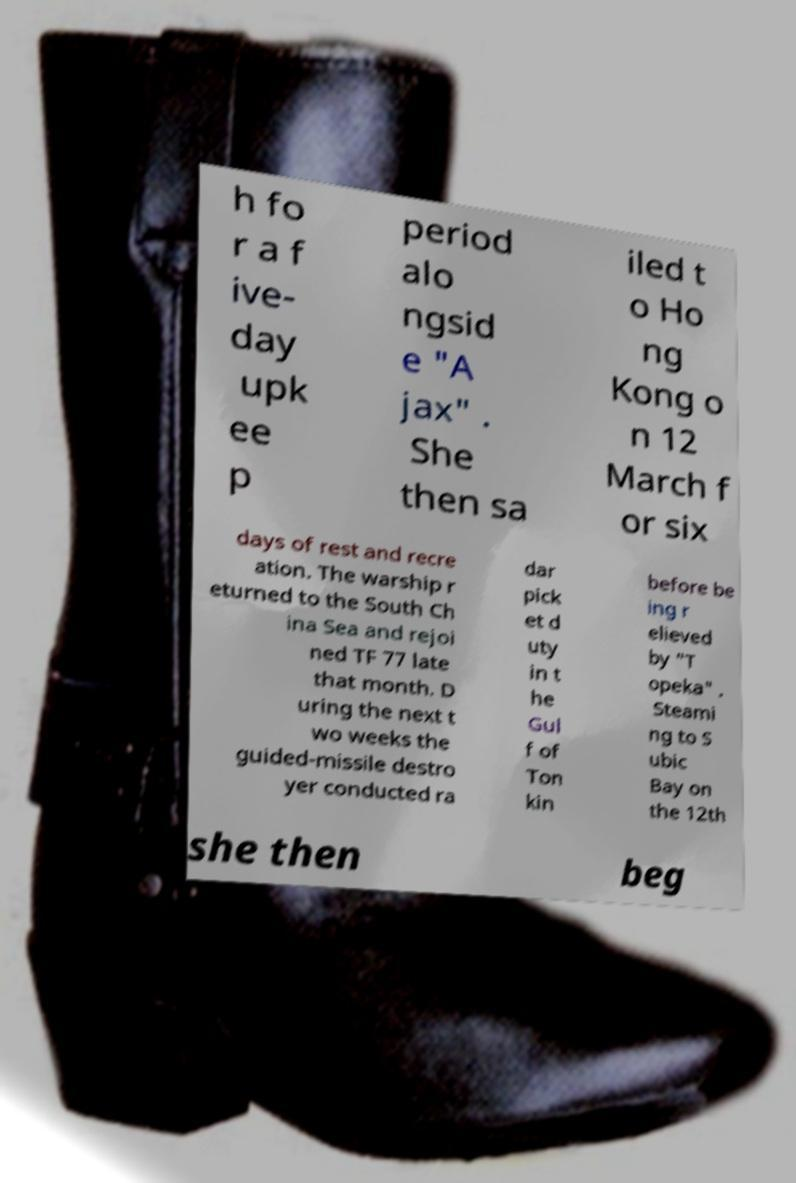What messages or text are displayed in this image? I need them in a readable, typed format. h fo r a f ive- day upk ee p period alo ngsid e "A jax" . She then sa iled t o Ho ng Kong o n 12 March f or six days of rest and recre ation. The warship r eturned to the South Ch ina Sea and rejoi ned TF 77 late that month. D uring the next t wo weeks the guided-missile destro yer conducted ra dar pick et d uty in t he Gul f of Ton kin before be ing r elieved by "T opeka" . Steami ng to S ubic Bay on the 12th she then beg 